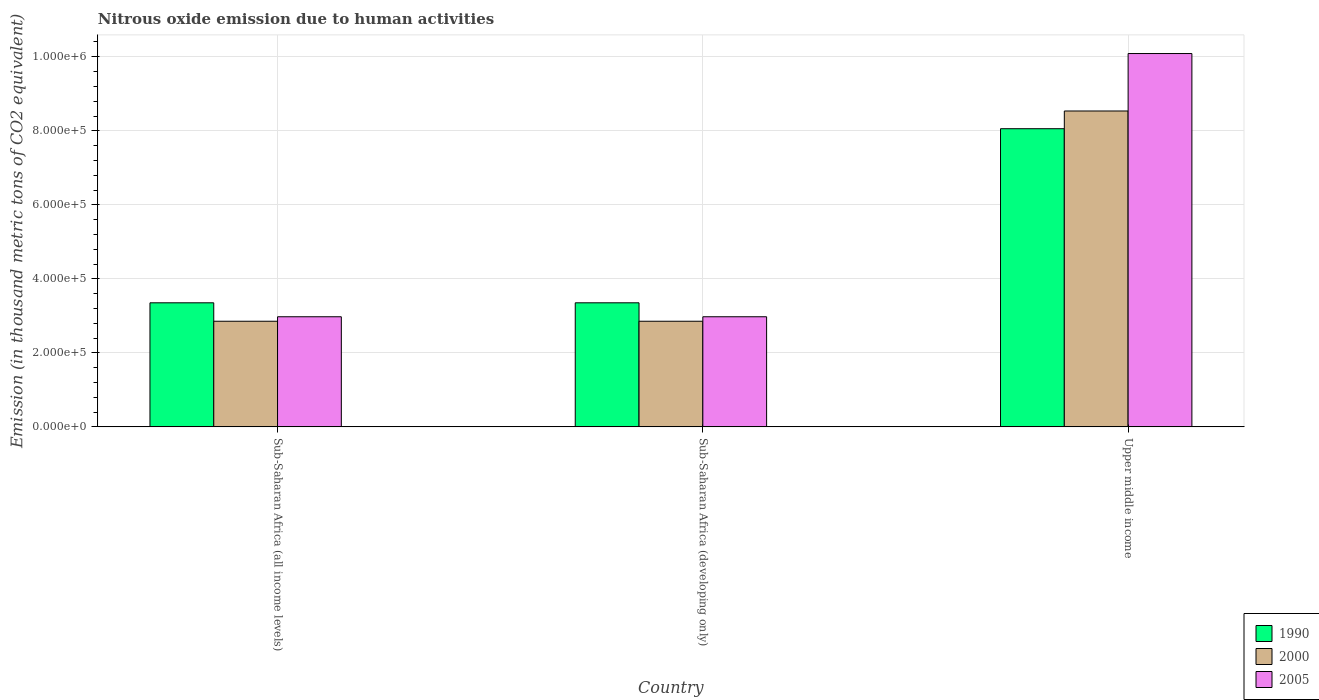Are the number of bars on each tick of the X-axis equal?
Provide a succinct answer. Yes. How many bars are there on the 3rd tick from the right?
Keep it short and to the point. 3. What is the label of the 3rd group of bars from the left?
Keep it short and to the point. Upper middle income. What is the amount of nitrous oxide emitted in 2005 in Sub-Saharan Africa (developing only)?
Offer a terse response. 2.98e+05. Across all countries, what is the maximum amount of nitrous oxide emitted in 2000?
Give a very brief answer. 8.54e+05. Across all countries, what is the minimum amount of nitrous oxide emitted in 2000?
Make the answer very short. 2.85e+05. In which country was the amount of nitrous oxide emitted in 2005 maximum?
Your response must be concise. Upper middle income. In which country was the amount of nitrous oxide emitted in 2000 minimum?
Provide a succinct answer. Sub-Saharan Africa (all income levels). What is the total amount of nitrous oxide emitted in 1990 in the graph?
Your answer should be very brief. 1.48e+06. What is the difference between the amount of nitrous oxide emitted in 2005 in Sub-Saharan Africa (all income levels) and that in Upper middle income?
Provide a short and direct response. -7.11e+05. What is the difference between the amount of nitrous oxide emitted in 1990 in Sub-Saharan Africa (developing only) and the amount of nitrous oxide emitted in 2000 in Upper middle income?
Offer a very short reply. -5.18e+05. What is the average amount of nitrous oxide emitted in 2000 per country?
Your answer should be compact. 4.75e+05. What is the difference between the amount of nitrous oxide emitted of/in 1990 and amount of nitrous oxide emitted of/in 2005 in Upper middle income?
Give a very brief answer. -2.03e+05. What is the ratio of the amount of nitrous oxide emitted in 2005 in Sub-Saharan Africa (developing only) to that in Upper middle income?
Give a very brief answer. 0.29. Is the amount of nitrous oxide emitted in 2000 in Sub-Saharan Africa (developing only) less than that in Upper middle income?
Offer a terse response. Yes. What is the difference between the highest and the second highest amount of nitrous oxide emitted in 1990?
Provide a succinct answer. -4.70e+05. What is the difference between the highest and the lowest amount of nitrous oxide emitted in 2000?
Give a very brief answer. 5.68e+05. In how many countries, is the amount of nitrous oxide emitted in 2000 greater than the average amount of nitrous oxide emitted in 2000 taken over all countries?
Ensure brevity in your answer.  1. Is the sum of the amount of nitrous oxide emitted in 2005 in Sub-Saharan Africa (all income levels) and Upper middle income greater than the maximum amount of nitrous oxide emitted in 2000 across all countries?
Provide a succinct answer. Yes. Is it the case that in every country, the sum of the amount of nitrous oxide emitted in 2005 and amount of nitrous oxide emitted in 2000 is greater than the amount of nitrous oxide emitted in 1990?
Your answer should be compact. Yes. How many bars are there?
Provide a succinct answer. 9. How are the legend labels stacked?
Keep it short and to the point. Vertical. What is the title of the graph?
Your response must be concise. Nitrous oxide emission due to human activities. What is the label or title of the Y-axis?
Keep it short and to the point. Emission (in thousand metric tons of CO2 equivalent). What is the Emission (in thousand metric tons of CO2 equivalent) of 1990 in Sub-Saharan Africa (all income levels)?
Keep it short and to the point. 3.35e+05. What is the Emission (in thousand metric tons of CO2 equivalent) of 2000 in Sub-Saharan Africa (all income levels)?
Keep it short and to the point. 2.85e+05. What is the Emission (in thousand metric tons of CO2 equivalent) in 2005 in Sub-Saharan Africa (all income levels)?
Your answer should be compact. 2.98e+05. What is the Emission (in thousand metric tons of CO2 equivalent) in 1990 in Sub-Saharan Africa (developing only)?
Give a very brief answer. 3.35e+05. What is the Emission (in thousand metric tons of CO2 equivalent) of 2000 in Sub-Saharan Africa (developing only)?
Offer a terse response. 2.85e+05. What is the Emission (in thousand metric tons of CO2 equivalent) in 2005 in Sub-Saharan Africa (developing only)?
Provide a short and direct response. 2.98e+05. What is the Emission (in thousand metric tons of CO2 equivalent) in 1990 in Upper middle income?
Offer a terse response. 8.06e+05. What is the Emission (in thousand metric tons of CO2 equivalent) in 2000 in Upper middle income?
Your response must be concise. 8.54e+05. What is the Emission (in thousand metric tons of CO2 equivalent) in 2005 in Upper middle income?
Make the answer very short. 1.01e+06. Across all countries, what is the maximum Emission (in thousand metric tons of CO2 equivalent) in 1990?
Make the answer very short. 8.06e+05. Across all countries, what is the maximum Emission (in thousand metric tons of CO2 equivalent) in 2000?
Your answer should be very brief. 8.54e+05. Across all countries, what is the maximum Emission (in thousand metric tons of CO2 equivalent) in 2005?
Your answer should be compact. 1.01e+06. Across all countries, what is the minimum Emission (in thousand metric tons of CO2 equivalent) in 1990?
Keep it short and to the point. 3.35e+05. Across all countries, what is the minimum Emission (in thousand metric tons of CO2 equivalent) in 2000?
Provide a succinct answer. 2.85e+05. Across all countries, what is the minimum Emission (in thousand metric tons of CO2 equivalent) in 2005?
Make the answer very short. 2.98e+05. What is the total Emission (in thousand metric tons of CO2 equivalent) in 1990 in the graph?
Your response must be concise. 1.48e+06. What is the total Emission (in thousand metric tons of CO2 equivalent) of 2000 in the graph?
Make the answer very short. 1.42e+06. What is the total Emission (in thousand metric tons of CO2 equivalent) in 2005 in the graph?
Offer a terse response. 1.60e+06. What is the difference between the Emission (in thousand metric tons of CO2 equivalent) of 2005 in Sub-Saharan Africa (all income levels) and that in Sub-Saharan Africa (developing only)?
Your answer should be compact. 0. What is the difference between the Emission (in thousand metric tons of CO2 equivalent) of 1990 in Sub-Saharan Africa (all income levels) and that in Upper middle income?
Your response must be concise. -4.70e+05. What is the difference between the Emission (in thousand metric tons of CO2 equivalent) in 2000 in Sub-Saharan Africa (all income levels) and that in Upper middle income?
Provide a short and direct response. -5.68e+05. What is the difference between the Emission (in thousand metric tons of CO2 equivalent) of 2005 in Sub-Saharan Africa (all income levels) and that in Upper middle income?
Provide a short and direct response. -7.11e+05. What is the difference between the Emission (in thousand metric tons of CO2 equivalent) of 1990 in Sub-Saharan Africa (developing only) and that in Upper middle income?
Provide a succinct answer. -4.70e+05. What is the difference between the Emission (in thousand metric tons of CO2 equivalent) of 2000 in Sub-Saharan Africa (developing only) and that in Upper middle income?
Keep it short and to the point. -5.68e+05. What is the difference between the Emission (in thousand metric tons of CO2 equivalent) in 2005 in Sub-Saharan Africa (developing only) and that in Upper middle income?
Provide a short and direct response. -7.11e+05. What is the difference between the Emission (in thousand metric tons of CO2 equivalent) of 1990 in Sub-Saharan Africa (all income levels) and the Emission (in thousand metric tons of CO2 equivalent) of 2000 in Sub-Saharan Africa (developing only)?
Make the answer very short. 4.98e+04. What is the difference between the Emission (in thousand metric tons of CO2 equivalent) of 1990 in Sub-Saharan Africa (all income levels) and the Emission (in thousand metric tons of CO2 equivalent) of 2005 in Sub-Saharan Africa (developing only)?
Ensure brevity in your answer.  3.77e+04. What is the difference between the Emission (in thousand metric tons of CO2 equivalent) of 2000 in Sub-Saharan Africa (all income levels) and the Emission (in thousand metric tons of CO2 equivalent) of 2005 in Sub-Saharan Africa (developing only)?
Your response must be concise. -1.21e+04. What is the difference between the Emission (in thousand metric tons of CO2 equivalent) of 1990 in Sub-Saharan Africa (all income levels) and the Emission (in thousand metric tons of CO2 equivalent) of 2000 in Upper middle income?
Your answer should be compact. -5.18e+05. What is the difference between the Emission (in thousand metric tons of CO2 equivalent) in 1990 in Sub-Saharan Africa (all income levels) and the Emission (in thousand metric tons of CO2 equivalent) in 2005 in Upper middle income?
Make the answer very short. -6.74e+05. What is the difference between the Emission (in thousand metric tons of CO2 equivalent) of 2000 in Sub-Saharan Africa (all income levels) and the Emission (in thousand metric tons of CO2 equivalent) of 2005 in Upper middle income?
Provide a short and direct response. -7.23e+05. What is the difference between the Emission (in thousand metric tons of CO2 equivalent) in 1990 in Sub-Saharan Africa (developing only) and the Emission (in thousand metric tons of CO2 equivalent) in 2000 in Upper middle income?
Offer a terse response. -5.18e+05. What is the difference between the Emission (in thousand metric tons of CO2 equivalent) of 1990 in Sub-Saharan Africa (developing only) and the Emission (in thousand metric tons of CO2 equivalent) of 2005 in Upper middle income?
Make the answer very short. -6.74e+05. What is the difference between the Emission (in thousand metric tons of CO2 equivalent) in 2000 in Sub-Saharan Africa (developing only) and the Emission (in thousand metric tons of CO2 equivalent) in 2005 in Upper middle income?
Offer a very short reply. -7.23e+05. What is the average Emission (in thousand metric tons of CO2 equivalent) of 1990 per country?
Provide a short and direct response. 4.92e+05. What is the average Emission (in thousand metric tons of CO2 equivalent) in 2000 per country?
Offer a very short reply. 4.75e+05. What is the average Emission (in thousand metric tons of CO2 equivalent) of 2005 per country?
Make the answer very short. 5.35e+05. What is the difference between the Emission (in thousand metric tons of CO2 equivalent) in 1990 and Emission (in thousand metric tons of CO2 equivalent) in 2000 in Sub-Saharan Africa (all income levels)?
Keep it short and to the point. 4.98e+04. What is the difference between the Emission (in thousand metric tons of CO2 equivalent) in 1990 and Emission (in thousand metric tons of CO2 equivalent) in 2005 in Sub-Saharan Africa (all income levels)?
Offer a terse response. 3.77e+04. What is the difference between the Emission (in thousand metric tons of CO2 equivalent) in 2000 and Emission (in thousand metric tons of CO2 equivalent) in 2005 in Sub-Saharan Africa (all income levels)?
Make the answer very short. -1.21e+04. What is the difference between the Emission (in thousand metric tons of CO2 equivalent) of 1990 and Emission (in thousand metric tons of CO2 equivalent) of 2000 in Sub-Saharan Africa (developing only)?
Provide a succinct answer. 4.98e+04. What is the difference between the Emission (in thousand metric tons of CO2 equivalent) in 1990 and Emission (in thousand metric tons of CO2 equivalent) in 2005 in Sub-Saharan Africa (developing only)?
Make the answer very short. 3.77e+04. What is the difference between the Emission (in thousand metric tons of CO2 equivalent) of 2000 and Emission (in thousand metric tons of CO2 equivalent) of 2005 in Sub-Saharan Africa (developing only)?
Your answer should be very brief. -1.21e+04. What is the difference between the Emission (in thousand metric tons of CO2 equivalent) of 1990 and Emission (in thousand metric tons of CO2 equivalent) of 2000 in Upper middle income?
Provide a short and direct response. -4.79e+04. What is the difference between the Emission (in thousand metric tons of CO2 equivalent) in 1990 and Emission (in thousand metric tons of CO2 equivalent) in 2005 in Upper middle income?
Your answer should be very brief. -2.03e+05. What is the difference between the Emission (in thousand metric tons of CO2 equivalent) of 2000 and Emission (in thousand metric tons of CO2 equivalent) of 2005 in Upper middle income?
Your answer should be very brief. -1.55e+05. What is the ratio of the Emission (in thousand metric tons of CO2 equivalent) in 1990 in Sub-Saharan Africa (all income levels) to that in Sub-Saharan Africa (developing only)?
Your response must be concise. 1. What is the ratio of the Emission (in thousand metric tons of CO2 equivalent) in 1990 in Sub-Saharan Africa (all income levels) to that in Upper middle income?
Keep it short and to the point. 0.42. What is the ratio of the Emission (in thousand metric tons of CO2 equivalent) in 2000 in Sub-Saharan Africa (all income levels) to that in Upper middle income?
Your answer should be very brief. 0.33. What is the ratio of the Emission (in thousand metric tons of CO2 equivalent) of 2005 in Sub-Saharan Africa (all income levels) to that in Upper middle income?
Provide a succinct answer. 0.29. What is the ratio of the Emission (in thousand metric tons of CO2 equivalent) in 1990 in Sub-Saharan Africa (developing only) to that in Upper middle income?
Give a very brief answer. 0.42. What is the ratio of the Emission (in thousand metric tons of CO2 equivalent) of 2000 in Sub-Saharan Africa (developing only) to that in Upper middle income?
Provide a short and direct response. 0.33. What is the ratio of the Emission (in thousand metric tons of CO2 equivalent) of 2005 in Sub-Saharan Africa (developing only) to that in Upper middle income?
Your answer should be very brief. 0.29. What is the difference between the highest and the second highest Emission (in thousand metric tons of CO2 equivalent) of 1990?
Ensure brevity in your answer.  4.70e+05. What is the difference between the highest and the second highest Emission (in thousand metric tons of CO2 equivalent) in 2000?
Ensure brevity in your answer.  5.68e+05. What is the difference between the highest and the second highest Emission (in thousand metric tons of CO2 equivalent) of 2005?
Give a very brief answer. 7.11e+05. What is the difference between the highest and the lowest Emission (in thousand metric tons of CO2 equivalent) in 1990?
Your response must be concise. 4.70e+05. What is the difference between the highest and the lowest Emission (in thousand metric tons of CO2 equivalent) of 2000?
Your answer should be compact. 5.68e+05. What is the difference between the highest and the lowest Emission (in thousand metric tons of CO2 equivalent) in 2005?
Your response must be concise. 7.11e+05. 